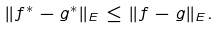<formula> <loc_0><loc_0><loc_500><loc_500>\| f ^ { * } - g ^ { * } \| _ { E } \leq \| f - g \| _ { E } .</formula> 